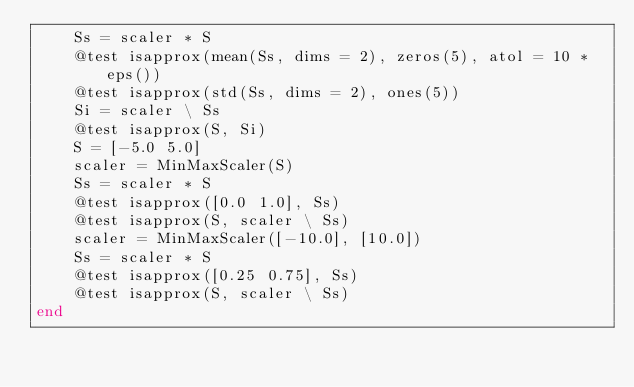<code> <loc_0><loc_0><loc_500><loc_500><_Julia_>    Ss = scaler * S
    @test isapprox(mean(Ss, dims = 2), zeros(5), atol = 10 * eps())
    @test isapprox(std(Ss, dims = 2), ones(5))
    Si = scaler \ Ss
    @test isapprox(S, Si)
    S = [-5.0 5.0]
    scaler = MinMaxScaler(S)
    Ss = scaler * S
    @test isapprox([0.0 1.0], Ss)
    @test isapprox(S, scaler \ Ss)
    scaler = MinMaxScaler([-10.0], [10.0])
    Ss = scaler * S
    @test isapprox([0.25 0.75], Ss)
    @test isapprox(S, scaler \ Ss)
end
</code> 